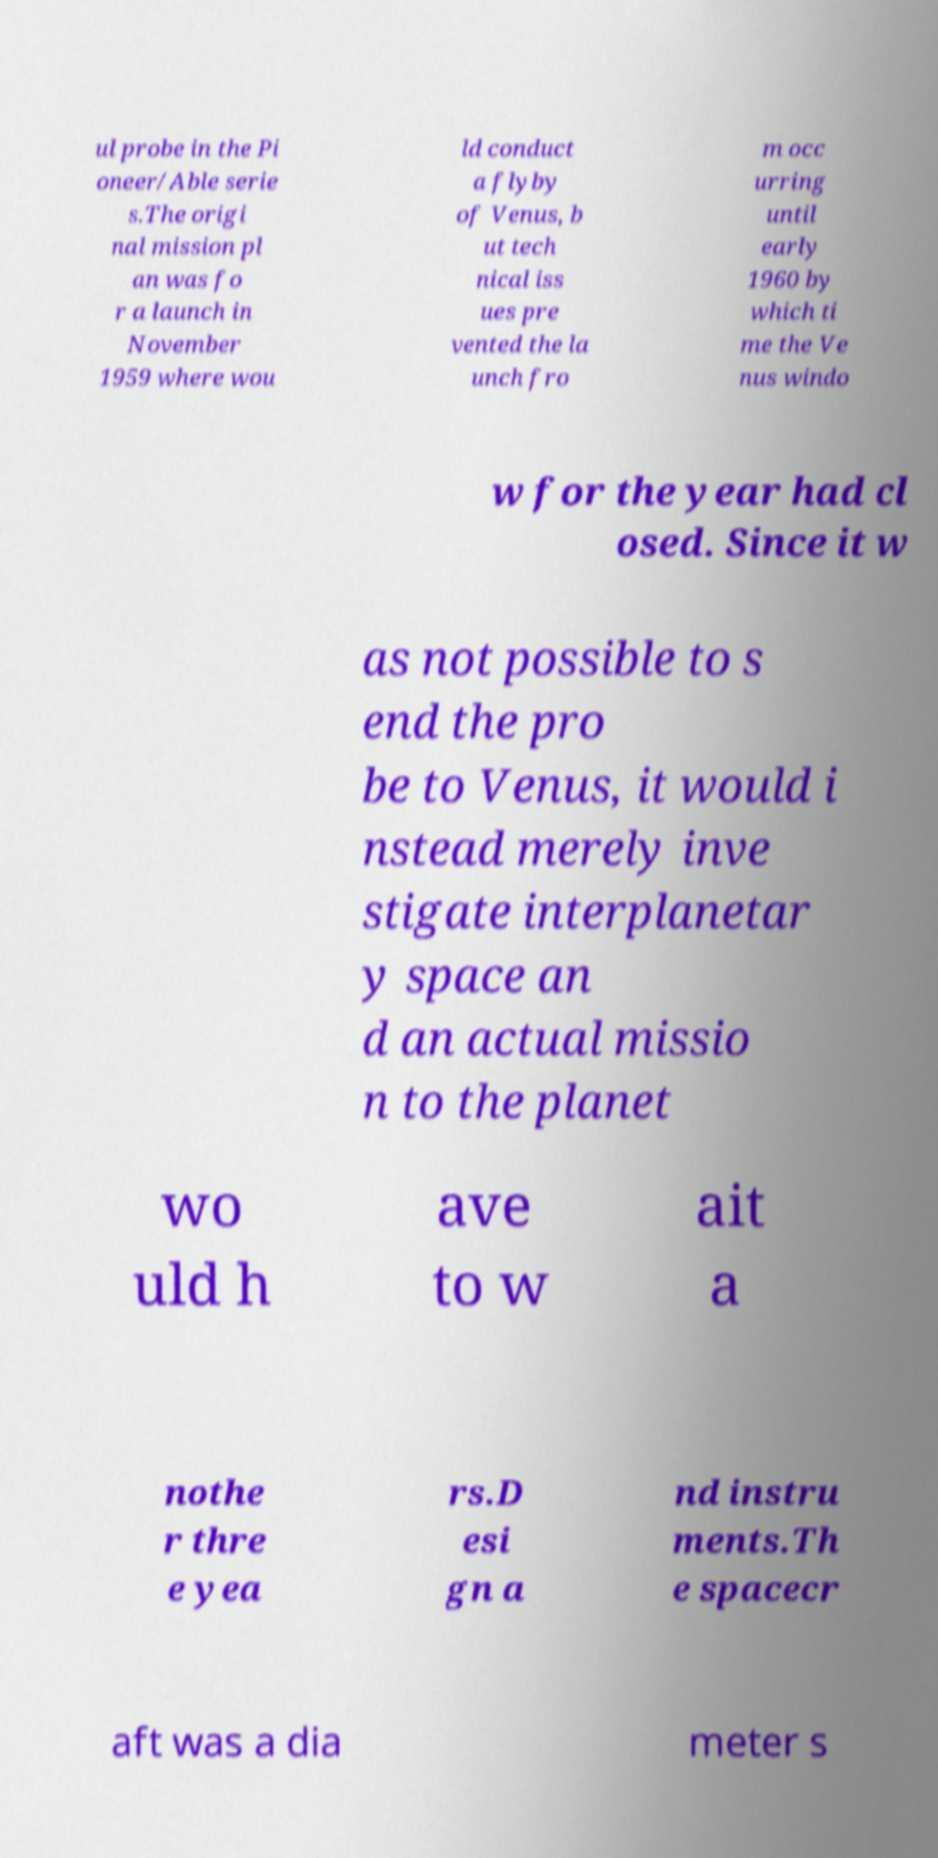Could you assist in decoding the text presented in this image and type it out clearly? ul probe in the Pi oneer/Able serie s.The origi nal mission pl an was fo r a launch in November 1959 where wou ld conduct a flyby of Venus, b ut tech nical iss ues pre vented the la unch fro m occ urring until early 1960 by which ti me the Ve nus windo w for the year had cl osed. Since it w as not possible to s end the pro be to Venus, it would i nstead merely inve stigate interplanetar y space an d an actual missio n to the planet wo uld h ave to w ait a nothe r thre e yea rs.D esi gn a nd instru ments.Th e spacecr aft was a dia meter s 